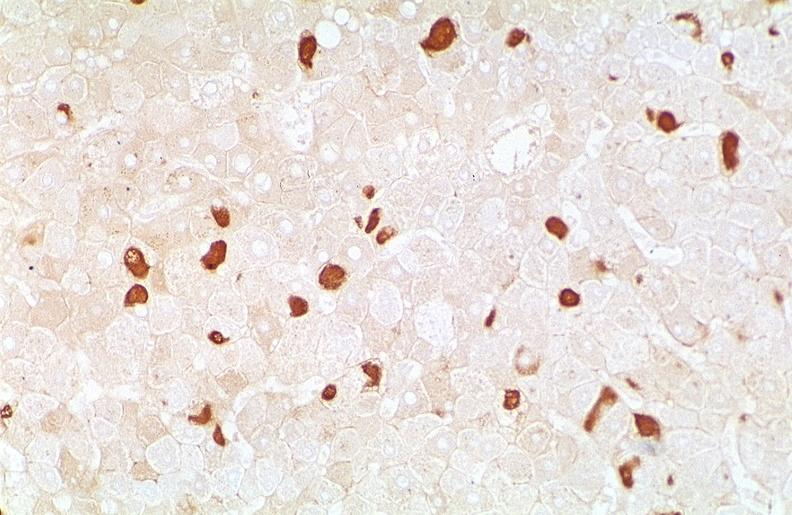does splenomegaly with cirrhosis show hepatitis b virus, hepatocellular carcinoma?
Answer the question using a single word or phrase. No 